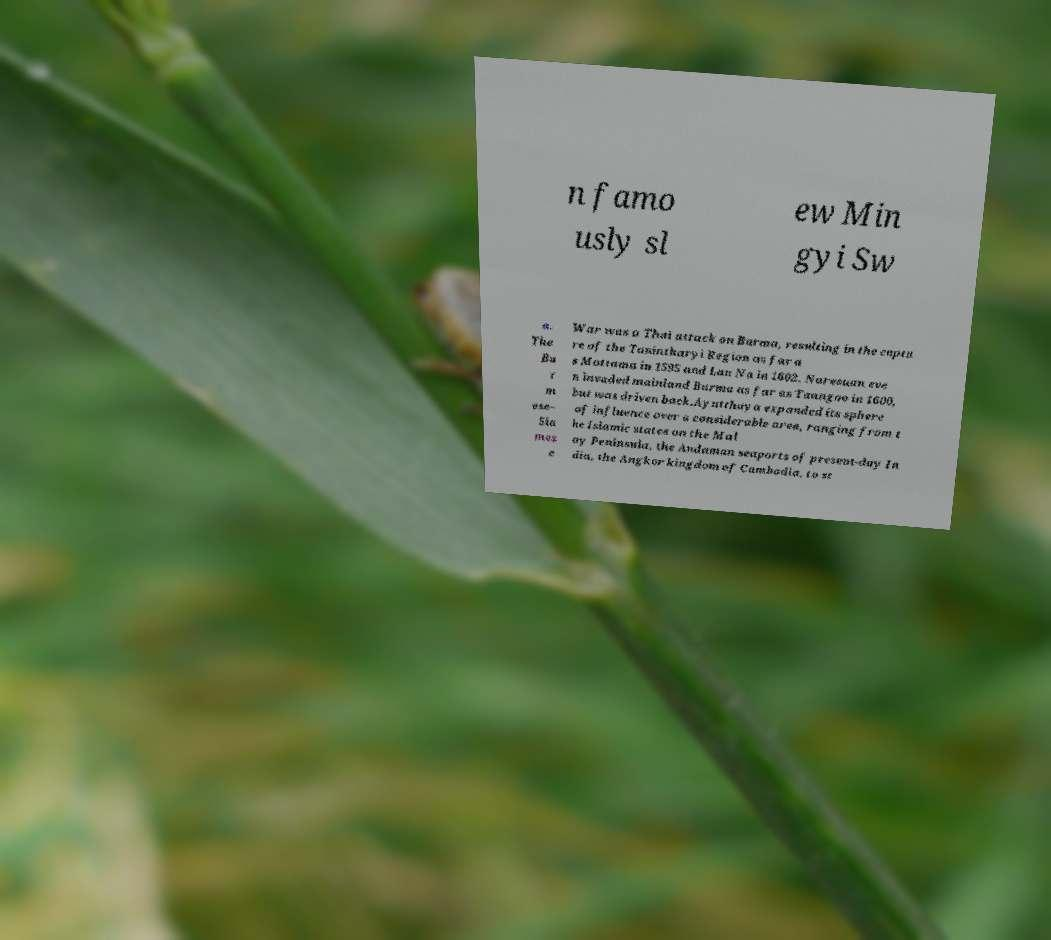Can you read and provide the text displayed in the image?This photo seems to have some interesting text. Can you extract and type it out for me? n famo usly sl ew Min gyi Sw a. The Bu r m ese– Sia mes e War was a Thai attack on Burma, resulting in the captu re of the Tanintharyi Region as far a s Mottama in 1595 and Lan Na in 1602. Naresuan eve n invaded mainland Burma as far as Taungoo in 1600, but was driven back.Ayutthaya expanded its sphere of influence over a considerable area, ranging from t he Islamic states on the Mal ay Peninsula, the Andaman seaports of present-day In dia, the Angkor kingdom of Cambodia, to st 